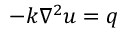<formula> <loc_0><loc_0><loc_500><loc_500>- k \nabla ^ { 2 } u = q</formula> 